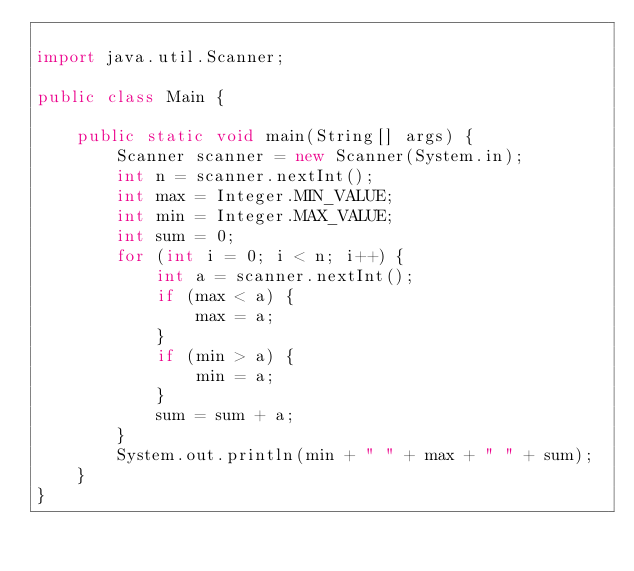Convert code to text. <code><loc_0><loc_0><loc_500><loc_500><_Java_>
import java.util.Scanner;

public class Main {

    public static void main(String[] args) {
        Scanner scanner = new Scanner(System.in);
        int n = scanner.nextInt();
        int max = Integer.MIN_VALUE;
        int min = Integer.MAX_VALUE;
        int sum = 0;
        for (int i = 0; i < n; i++) {
            int a = scanner.nextInt();
            if (max < a) {
                max = a;
            }
            if (min > a) {
                min = a;
            }
            sum = sum + a;
        }
        System.out.println(min + " " + max + " " + sum);
    }
}</code> 